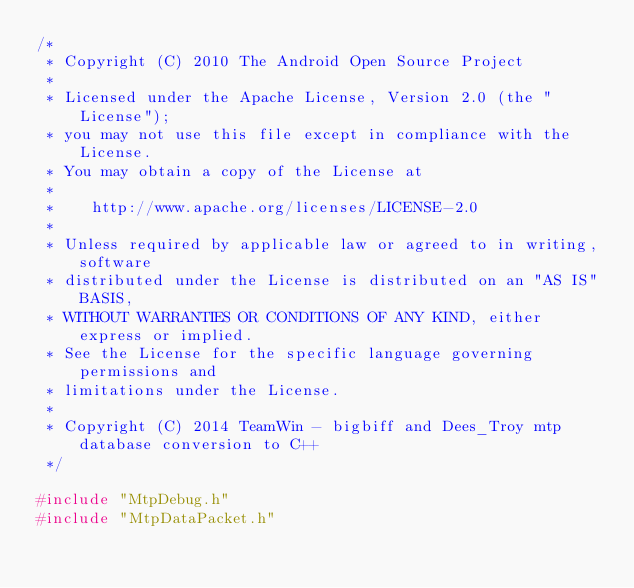Convert code to text. <code><loc_0><loc_0><loc_500><loc_500><_C++_>/*
 * Copyright (C) 2010 The Android Open Source Project
 *
 * Licensed under the Apache License, Version 2.0 (the "License");
 * you may not use this file except in compliance with the License.
 * You may obtain a copy of the License at
 *
 *	  http://www.apache.org/licenses/LICENSE-2.0
 *
 * Unless required by applicable law or agreed to in writing, software
 * distributed under the License is distributed on an "AS IS" BASIS,
 * WITHOUT WARRANTIES OR CONDITIONS OF ANY KIND, either express or implied.
 * See the License for the specific language governing permissions and
 * limitations under the License.
 *
 * Copyright (C) 2014 TeamWin - bigbiff and Dees_Troy mtp database conversion to C++
 */

#include "MtpDebug.h"
#include "MtpDataPacket.h"</code> 